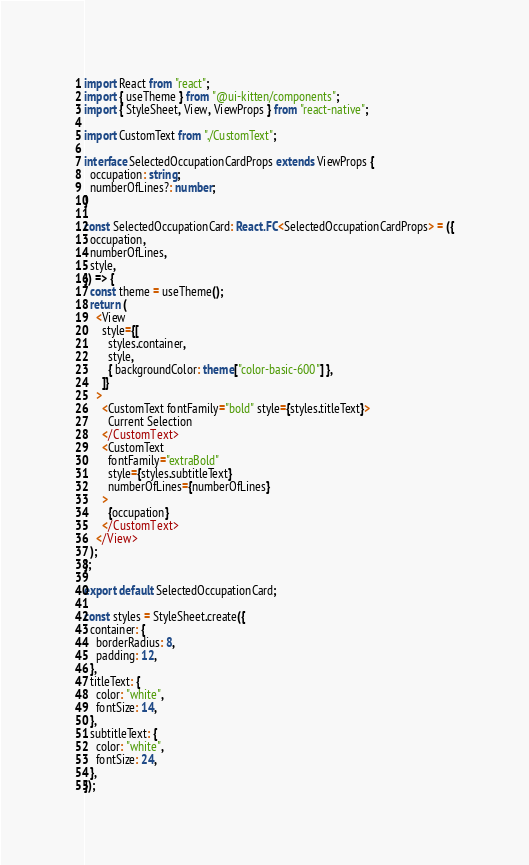Convert code to text. <code><loc_0><loc_0><loc_500><loc_500><_TypeScript_>import React from "react";
import { useTheme } from "@ui-kitten/components";
import { StyleSheet, View, ViewProps } from "react-native";

import CustomText from "./CustomText";

interface SelectedOccupationCardProps extends ViewProps {
  occupation: string;
  numberOfLines?: number;
}

const SelectedOccupationCard: React.FC<SelectedOccupationCardProps> = ({
  occupation,
  numberOfLines,
  style,
}) => {
  const theme = useTheme();
  return (
    <View
      style={[
        styles.container,
        style,
        { backgroundColor: theme["color-basic-600"] },
      ]}
    >
      <CustomText fontFamily="bold" style={styles.titleText}>
        Current Selection
      </CustomText>
      <CustomText
        fontFamily="extraBold"
        style={styles.subtitleText}
        numberOfLines={numberOfLines}
      >
        {occupation}
      </CustomText>
    </View>
  );
};

export default SelectedOccupationCard;

const styles = StyleSheet.create({
  container: {
    borderRadius: 8,
    padding: 12,
  },
  titleText: {
    color: "white",
    fontSize: 14,
  },
  subtitleText: {
    color: "white",
    fontSize: 24,
  },
});
</code> 